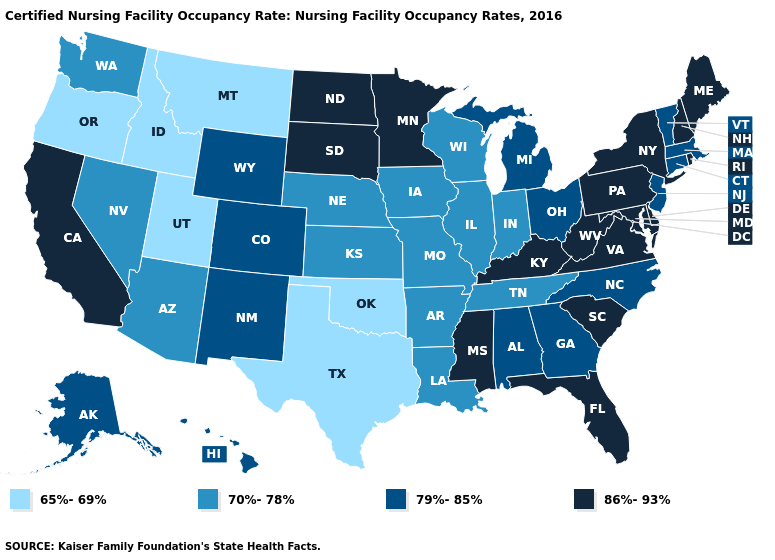What is the value of Pennsylvania?
Write a very short answer. 86%-93%. Name the states that have a value in the range 70%-78%?
Answer briefly. Arizona, Arkansas, Illinois, Indiana, Iowa, Kansas, Louisiana, Missouri, Nebraska, Nevada, Tennessee, Washington, Wisconsin. Does Ohio have a higher value than Utah?
Give a very brief answer. Yes. What is the highest value in the MidWest ?
Keep it brief. 86%-93%. What is the highest value in the West ?
Keep it brief. 86%-93%. Among the states that border Utah , does Wyoming have the highest value?
Keep it brief. Yes. Name the states that have a value in the range 79%-85%?
Be succinct. Alabama, Alaska, Colorado, Connecticut, Georgia, Hawaii, Massachusetts, Michigan, New Jersey, New Mexico, North Carolina, Ohio, Vermont, Wyoming. Name the states that have a value in the range 65%-69%?
Keep it brief. Idaho, Montana, Oklahoma, Oregon, Texas, Utah. Name the states that have a value in the range 70%-78%?
Concise answer only. Arizona, Arkansas, Illinois, Indiana, Iowa, Kansas, Louisiana, Missouri, Nebraska, Nevada, Tennessee, Washington, Wisconsin. What is the value of Colorado?
Quick response, please. 79%-85%. Does Arizona have a lower value than North Dakota?
Concise answer only. Yes. What is the lowest value in states that border New York?
Give a very brief answer. 79%-85%. What is the value of Wisconsin?
Keep it brief. 70%-78%. Is the legend a continuous bar?
Short answer required. No. 